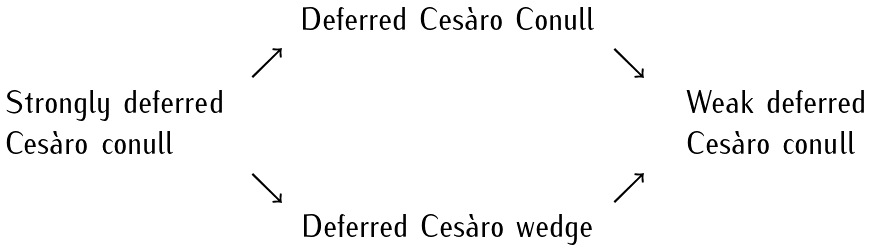<formula> <loc_0><loc_0><loc_500><loc_500>\begin{array} { c c c c c } & & \text {Deferred Ces\`{a}ro Conull} & & \\ & \nearrow & & \searrow & \\ \begin{array} { l l } & \text {Strongly  deferred} \\ & \text {Ces\`{a}ro conull} \end{array} & & & & \begin{array} { l l } & \text {Weak  deferred} \\ & \text {Ces\`{a}ro conull} \end{array} \\ & \searrow & & \nearrow & \\ & & \text {Deferred Ces\`{a}ro wedge} & & \end{array}</formula> 